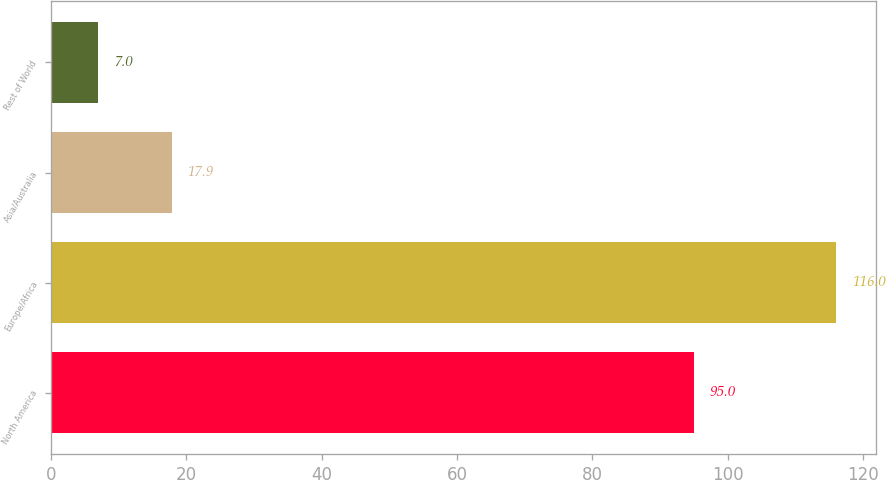<chart> <loc_0><loc_0><loc_500><loc_500><bar_chart><fcel>North America<fcel>Europe/Africa<fcel>Asia/Australia<fcel>Rest of World<nl><fcel>95<fcel>116<fcel>17.9<fcel>7<nl></chart> 